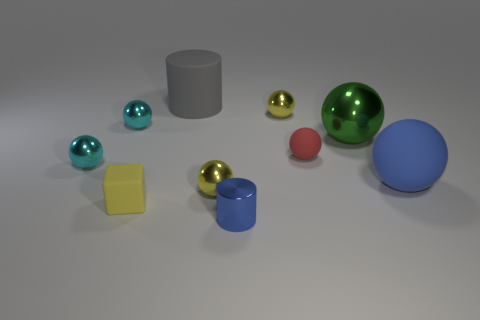Are the cylinder in front of the big metal object and the tiny cyan ball in front of the green shiny sphere made of the same material?
Provide a short and direct response. Yes. How big is the yellow shiny sphere on the left side of the blue metallic object?
Provide a short and direct response. Small. There is a tiny red thing that is the same shape as the large blue object; what is its material?
Your answer should be very brief. Rubber. Is there any other thing that has the same size as the matte cylinder?
Ensure brevity in your answer.  Yes. The blue object that is behind the matte cube has what shape?
Ensure brevity in your answer.  Sphere. What number of gray objects have the same shape as the small blue shiny thing?
Your answer should be very brief. 1. Is the number of red rubber balls that are behind the matte cylinder the same as the number of gray cylinders that are on the left side of the tiny yellow block?
Make the answer very short. Yes. Are there any large cylinders that have the same material as the large green object?
Your answer should be very brief. No. Do the blue cylinder and the big green object have the same material?
Keep it short and to the point. Yes. What number of cyan things are metal balls or big rubber balls?
Your answer should be compact. 2. 